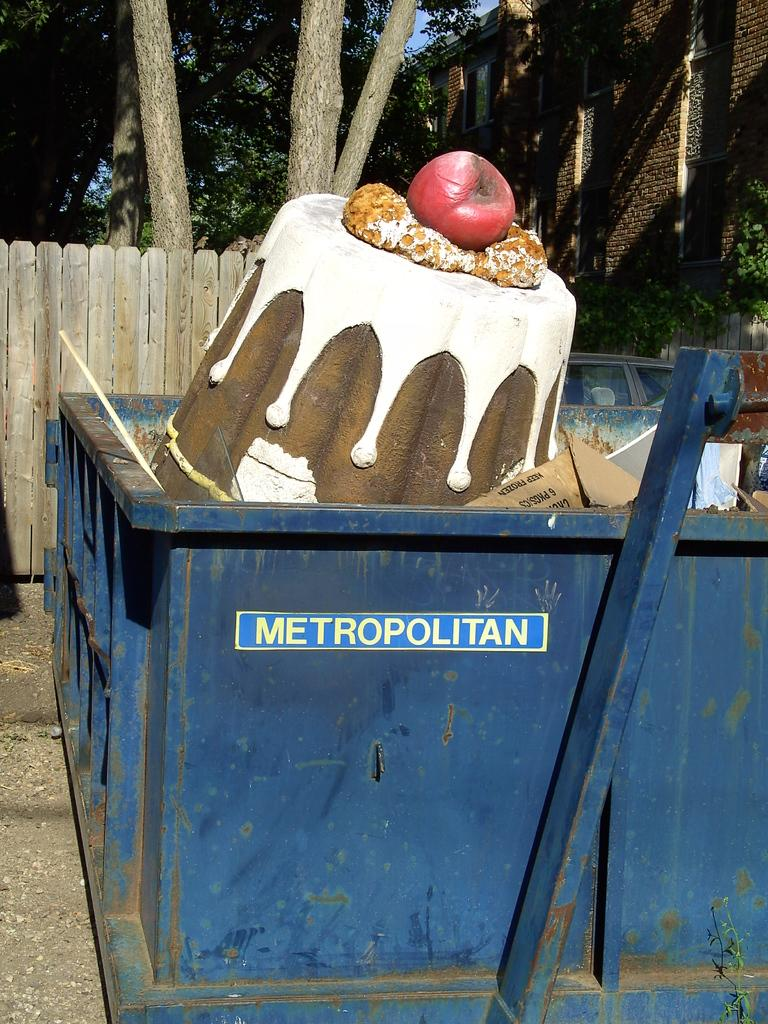What type of structure is visible in the image? There is a building in the image. What can be seen in the background of the image? There are many trees in the image. What object is present for waste disposal? There is a dustbin in the image. What type of fencing is present in the image? There is a wooden fencing in the image. How many clocks are hanging on the trees in the image? There are no clocks hanging on the trees in the image. What type of leg is visible on the building in the image? The image does not show any legs on the building, as it is a structure and not a living being. 